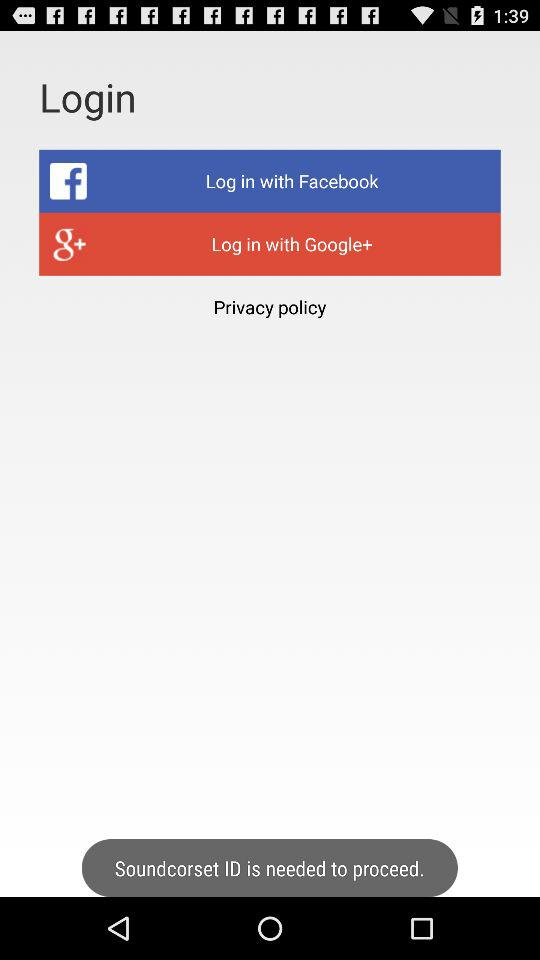Which application can be used to log in with? The applications that can be used to log in are "Facebook" and "Google+". 